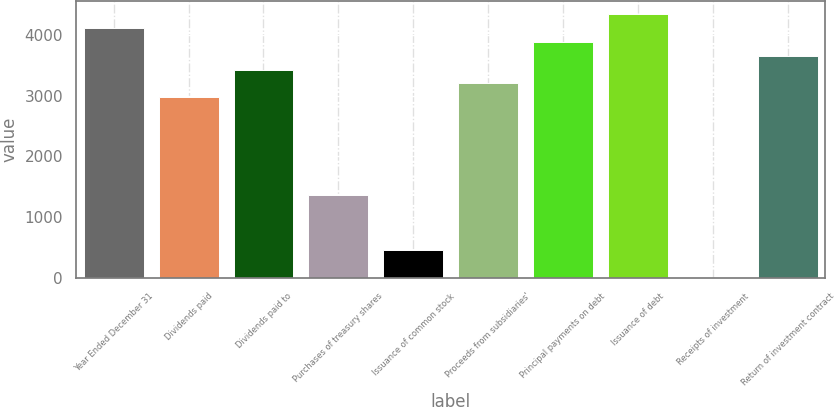Convert chart to OTSL. <chart><loc_0><loc_0><loc_500><loc_500><bar_chart><fcel>Year Ended December 31<fcel>Dividends paid<fcel>Dividends paid to<fcel>Purchases of treasury shares<fcel>Issuance of common stock<fcel>Proceeds from subsidiaries'<fcel>Principal payments on debt<fcel>Issuance of debt<fcel>Receipts of investment<fcel>Return of investment contract<nl><fcel>4110.6<fcel>2969.6<fcel>3426<fcel>1372.2<fcel>459.4<fcel>3197.8<fcel>3882.4<fcel>4338.8<fcel>3<fcel>3654.2<nl></chart> 